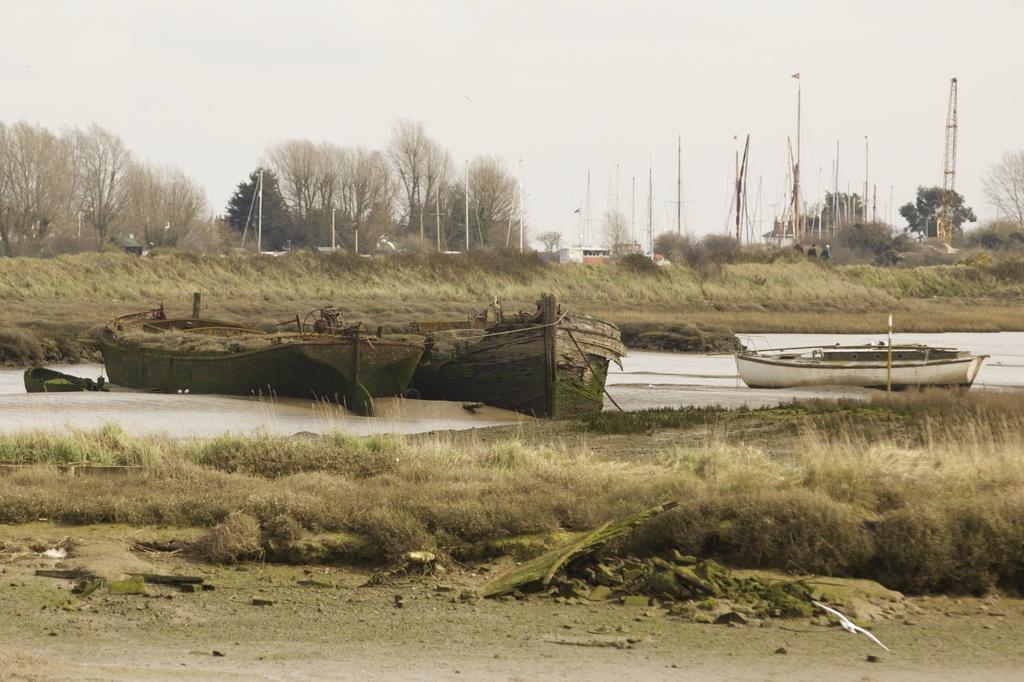What is on the water in the image? There are boats on the water in the image. What type of vegetation is visible in the image? Grass and trees are visible in the image. What type of ground surface can be seen in the image? Stones are present in the image. What is visible in the sky in the image? The sky is visible in the image. What are the poles used for in the image? The purpose of the poles is not specified in the image. What type of structure is present in the image? There is a house in the image. What type of art is displayed on the walls of the house in the image? There is no information about any art displayed on the walls of the house in the image. What type of fuel is used to power the boats in the image? There is no information about the type of fuel used to power the boats in the image. 